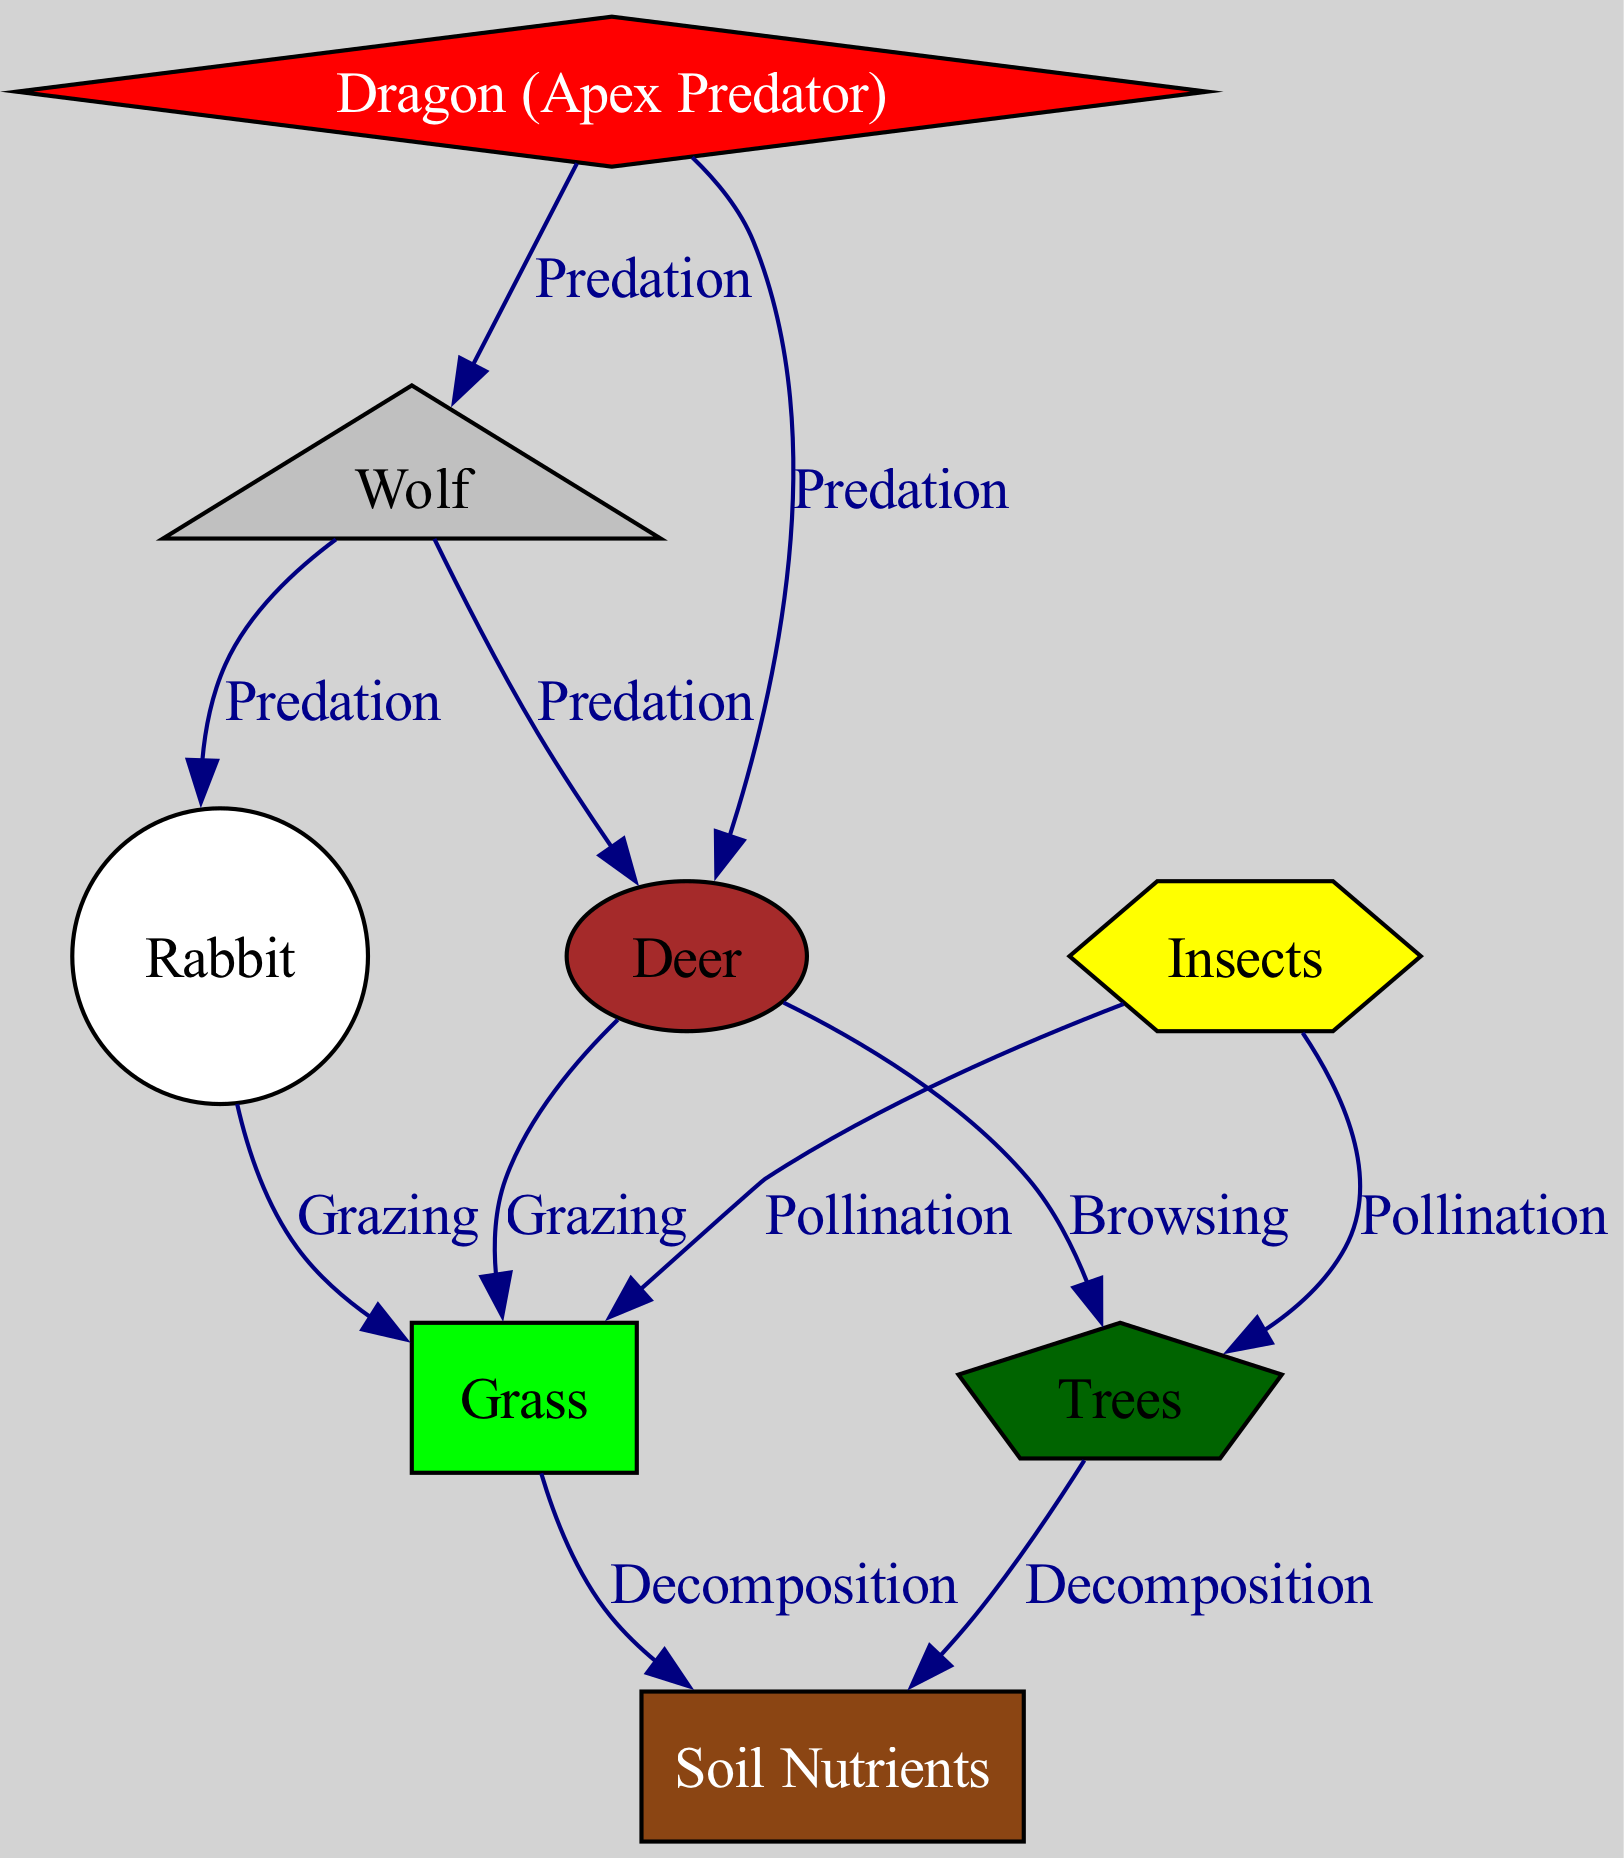What's the total number of nodes in the diagram? The diagram contains a collection of unique elements representing different organisms and components in the ecosystem. By counting each distinct node listed (dragon, deer, wolf, rabbit, grass, trees, insects, and soil), we find there are eight nodes in total.
Answer: Eight How many predation relationships are present? The diagram specifies connections indicative of predation, detailing how various creatures impact one another. The edges between dragon and deer, dragon and wolf, wolf and deer, and wolf and rabbit represent predation. By counting these specific edges, we determine there are four predation relationships.
Answer: Four What type of relationship exists between deer and grass? In the diagram, the edge connecting deer to grass indicates a grazing relationship, which signifies that deer consume grass as a food source. Visually, we see the connection marked with the label "Grazing."
Answer: Grazing Which node is affected by both deer and insects? The diagram depicts various relationships in the ecosystem. By analyzing the edges, we see that both deer and insects connect to grass, where deer graze and insects pollinate. Hence, grass is the node influenced by both.
Answer: Grass If the number of deer decreases, what is the likely ecological impact on grass? The diagram illustrates that deer graze on grass. Therefore, if the deer population decreases, their grazing pressure on grass would also reduce, likely leading to an increase in grass growth or biomass. This inference stems from observing the direct grazing relationship between deer and grass in the food web.
Answer: Increase in grass What is the function of insects in the ecosystem as represented in the diagram? The diagram shows that insects have relationships with both grass and trees. Specifically, they contribute to pollination, which is key for the reproduction of these plants. Thus, the role of insects is significant for maintaining the plant population health within the ecosystem, as they ensure reproduction via pollination.
Answer: Pollination How does the introduction of a dragon impact the wolf population? The diagram indicates that the dragon preys on wolves, establishing a direct predation relationship. If a dragon were introduced into this ecosystem, we could expect that the wolf population would likely decrease as a result of this new top predator's presence, leading to increased competition and predation pressures.
Answer: Decrease Which nodes lead to soil nutrients in the diagram? The diagram illustrates two main sources contributing to soil nutrients. The edges representing decomposition from both grass and trees lead to soil nutrients, indicating that these plants, after their life cycle, contribute organic matter that enriches the soil. By tracing the arrows in the diagram, we identify these two connections clearly.
Answer: Grass and Trees 